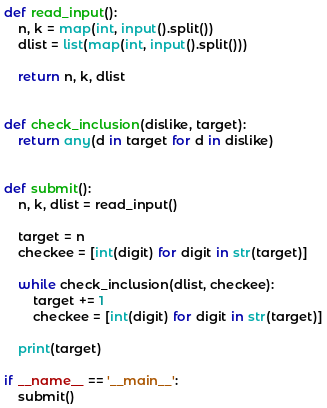Convert code to text. <code><loc_0><loc_0><loc_500><loc_500><_Python_>
def read_input():
    n, k = map(int, input().split())
    dlist = list(map(int, input().split()))

    return n, k, dlist


def check_inclusion(dislike, target):
    return any(d in target for d in dislike)


def submit():
    n, k, dlist = read_input()

    target = n
    checkee = [int(digit) for digit in str(target)]

    while check_inclusion(dlist, checkee):
        target += 1
        checkee = [int(digit) for digit in str(target)]

    print(target)

if __name__ == '__main__':
    submit()
</code> 